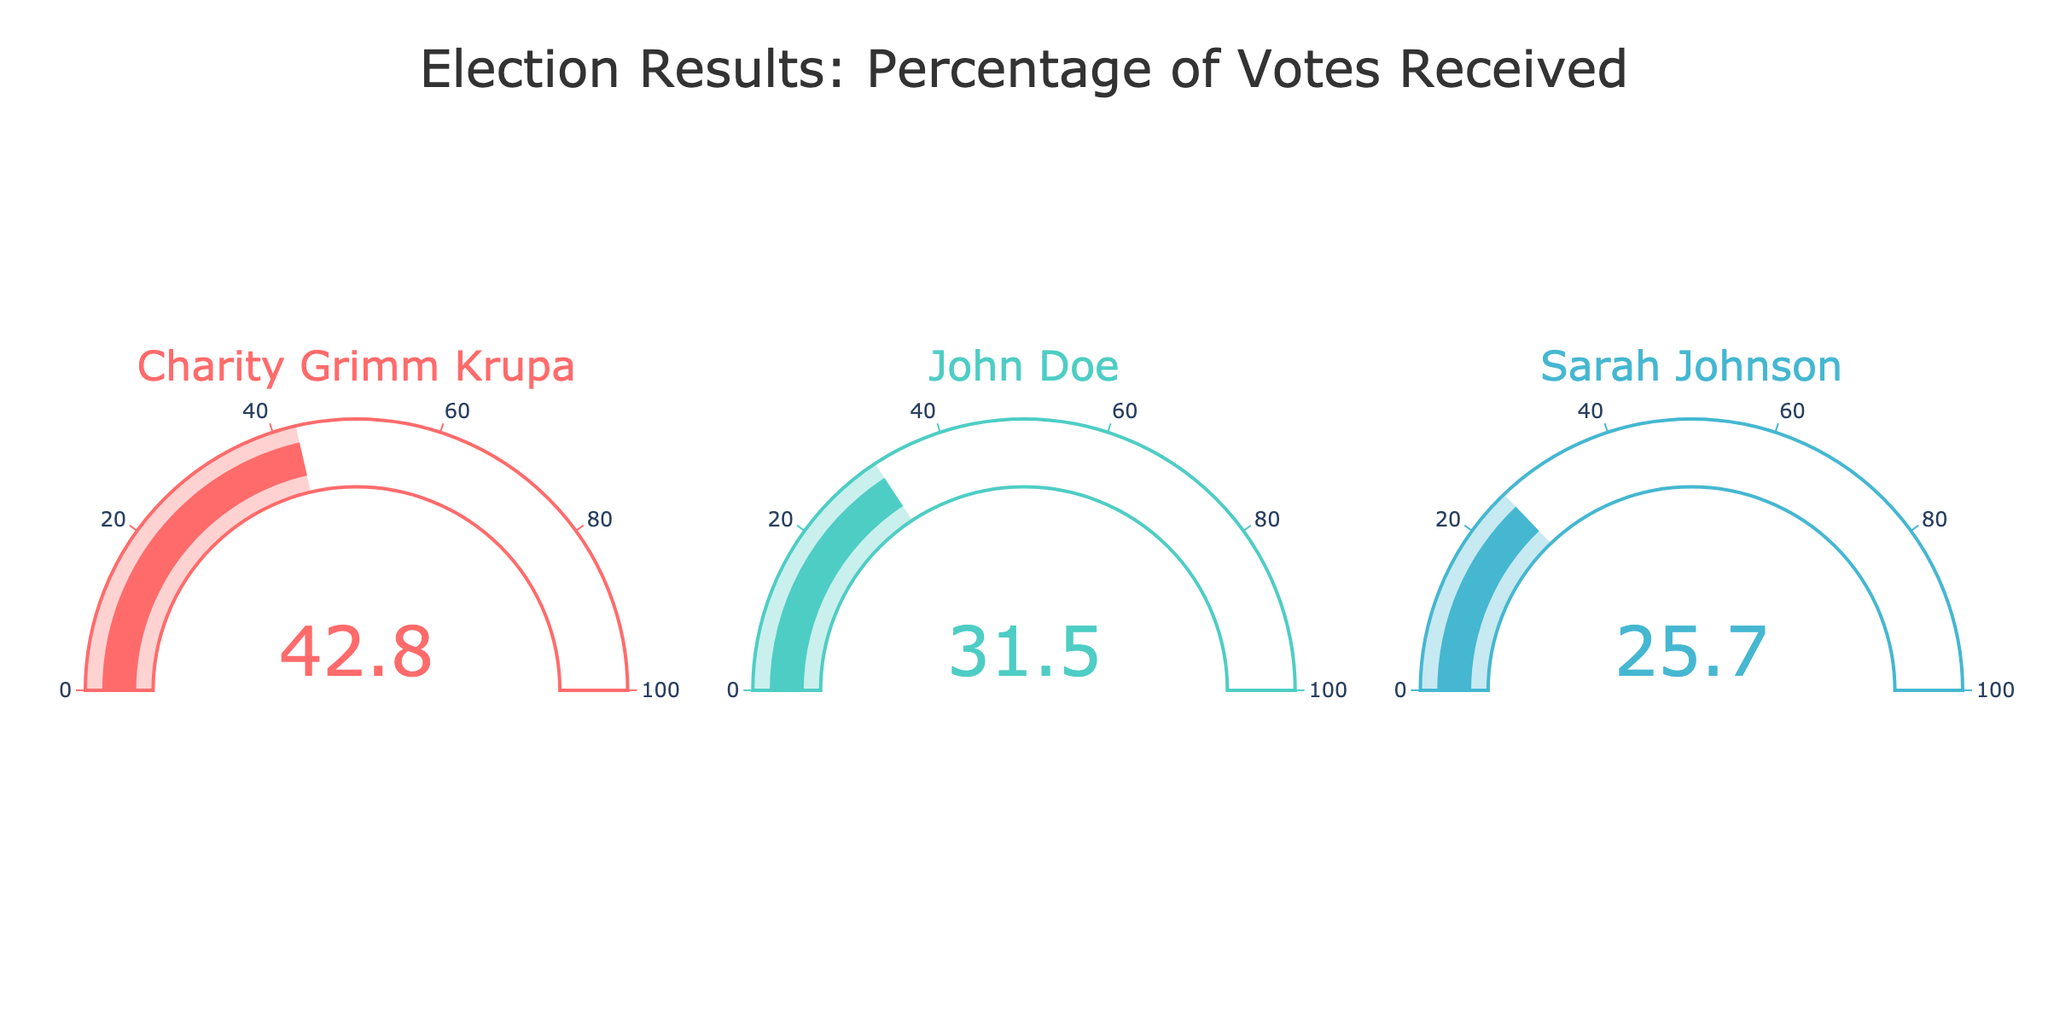What's the title of the figure? Look for the text at the top of the figure, which is the title. It reads "Election Results: Percentage of Votes Received".
Answer: Election Results: Percentage of Votes Received What is the percentage of votes received by Charity Grimm Krupa? Locate the gauge labeled "Charity Grimm Krupa" and read the number displayed. It shows 42.8.
Answer: 42.8 Which candidate received the least percentage of votes? Compare the numbers displayed on each gauge. Sarah Johnson's gauge shows the lowest percentage at 25.7.
Answer: Sarah Johnson What's the difference in percentage of votes between Charity Grimm Krupa and John Doe? Take Charity Grimm Krupa’s percentage (42.8) and subtract John Doe’s percentage (31.5). The difference is 42.8 - 31.5.
Answer: 11.3 How many candidates are shown in the figure? Count the number of gauges in the figure. Each gauge represents a candidate. There are three gauges in total.
Answer: 3 What's the average percentage of votes received by all candidates? Sum the percentages of all three candidates (42.8 + 31.5 + 25.7) and divide by the number of candidates (3). The sum is 100, so the average is 100 / 3.
Answer: 33.33 Is the percentage of votes for John Doe greater than the sum of Sarah Johnson's and half of the votes of Charity Grimm Krupa? Calculate half of Charity Grimm Krupa’s votes (42.8 / 2 = 21.4) and add it to Sarah Johnson’s votes (25.7). The sum is 21.4 + 25.7 = 47.1. Compare this with John Doe’s votes (31.5). 31.5 is less than 47.1.
Answer: No Which gauge has the highest percentage value displayed? Compare the numbers on all gauges. Charity Grimm Krupa's gauge shows the highest percentage at 42.8.
Answer: Charity Grimm Krupa What's the combined percentage of votes received by John Doe and Sarah Johnson? Add John Doe’s percentage (31.5) to Sarah Johnson’s percentage (25.7). The sum is 31.5 + 25.7.
Answer: 57.2 Is there a candidate who received more than 40% of the votes? Check each gauge to see if any candidate's percentage exceeds 40. Charity Grimm Krupa received 42.8%, which is more than 40.
Answer: Yes 